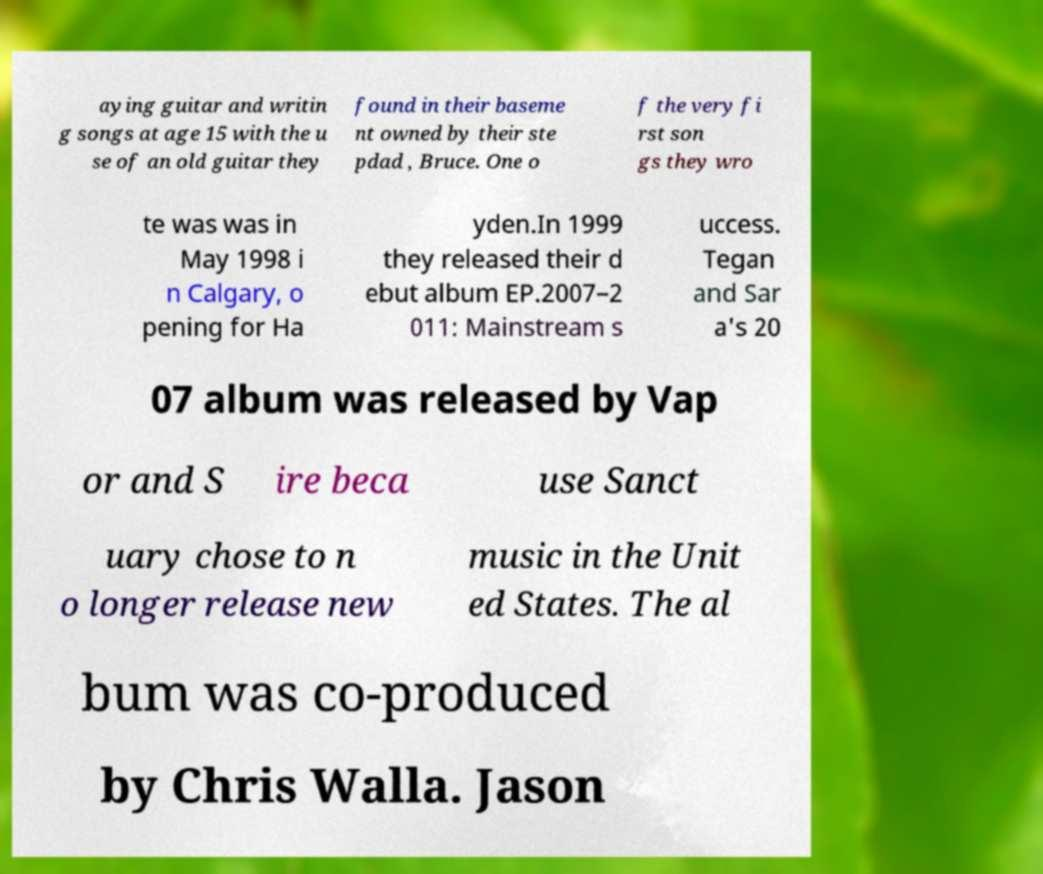For documentation purposes, I need the text within this image transcribed. Could you provide that? aying guitar and writin g songs at age 15 with the u se of an old guitar they found in their baseme nt owned by their ste pdad , Bruce. One o f the very fi rst son gs they wro te was was in May 1998 i n Calgary, o pening for Ha yden.In 1999 they released their d ebut album EP.2007–2 011: Mainstream s uccess. Tegan and Sar a's 20 07 album was released by Vap or and S ire beca use Sanct uary chose to n o longer release new music in the Unit ed States. The al bum was co-produced by Chris Walla. Jason 